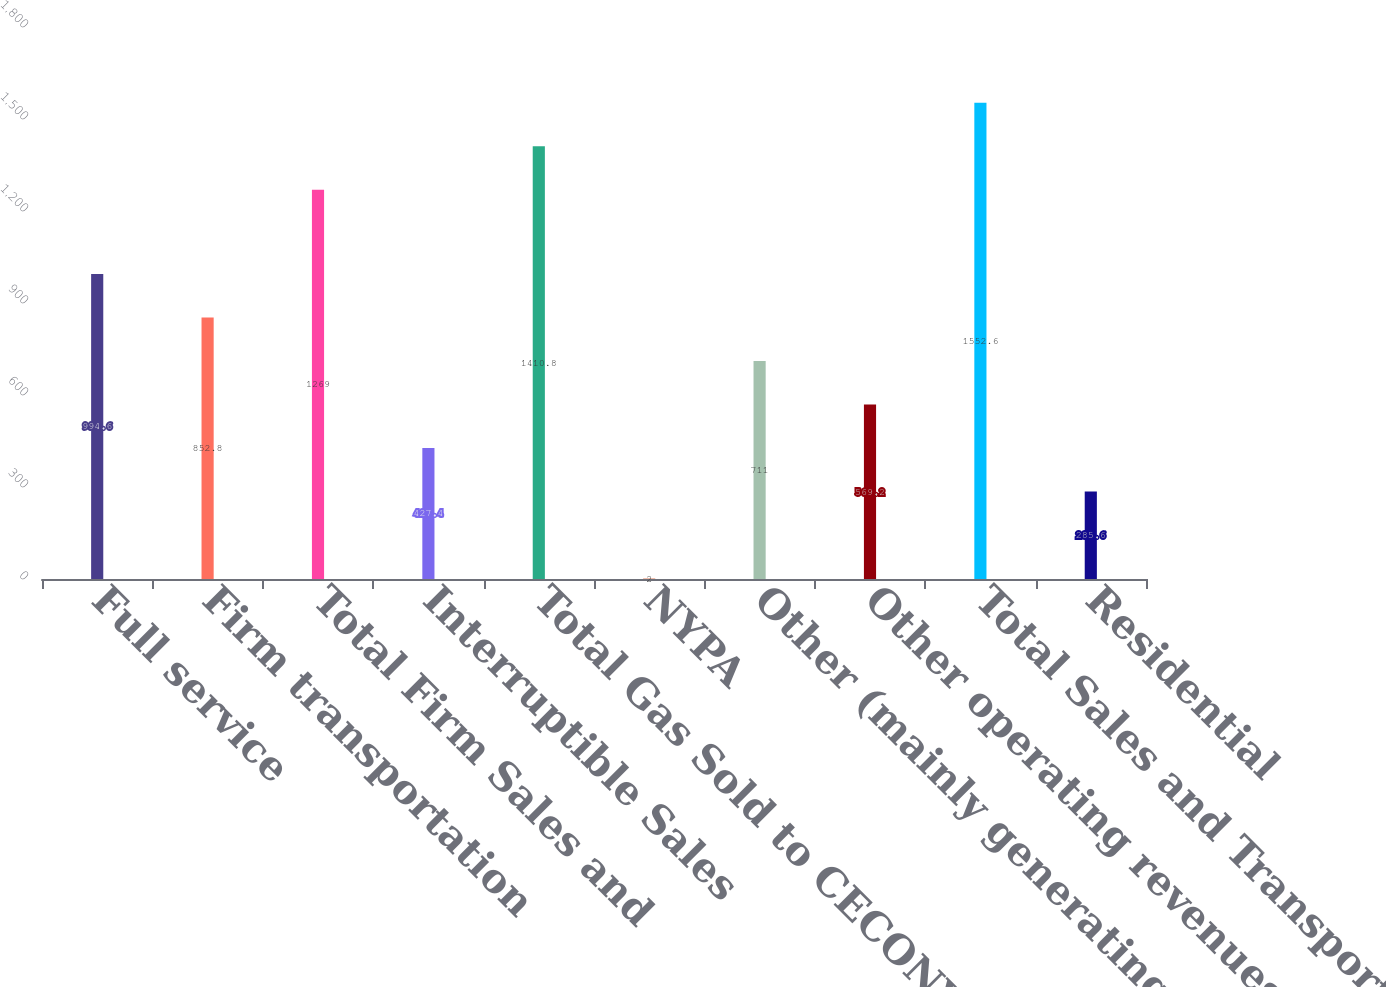Convert chart to OTSL. <chart><loc_0><loc_0><loc_500><loc_500><bar_chart><fcel>Full service<fcel>Firm transportation<fcel>Total Firm Sales and<fcel>Interruptible Sales<fcel>Total Gas Sold to CECONY<fcel>NYPA<fcel>Other (mainly generating<fcel>Other operating revenues<fcel>Total Sales and Transportation<fcel>Residential<nl><fcel>994.6<fcel>852.8<fcel>1269<fcel>427.4<fcel>1410.8<fcel>2<fcel>711<fcel>569.2<fcel>1552.6<fcel>285.6<nl></chart> 